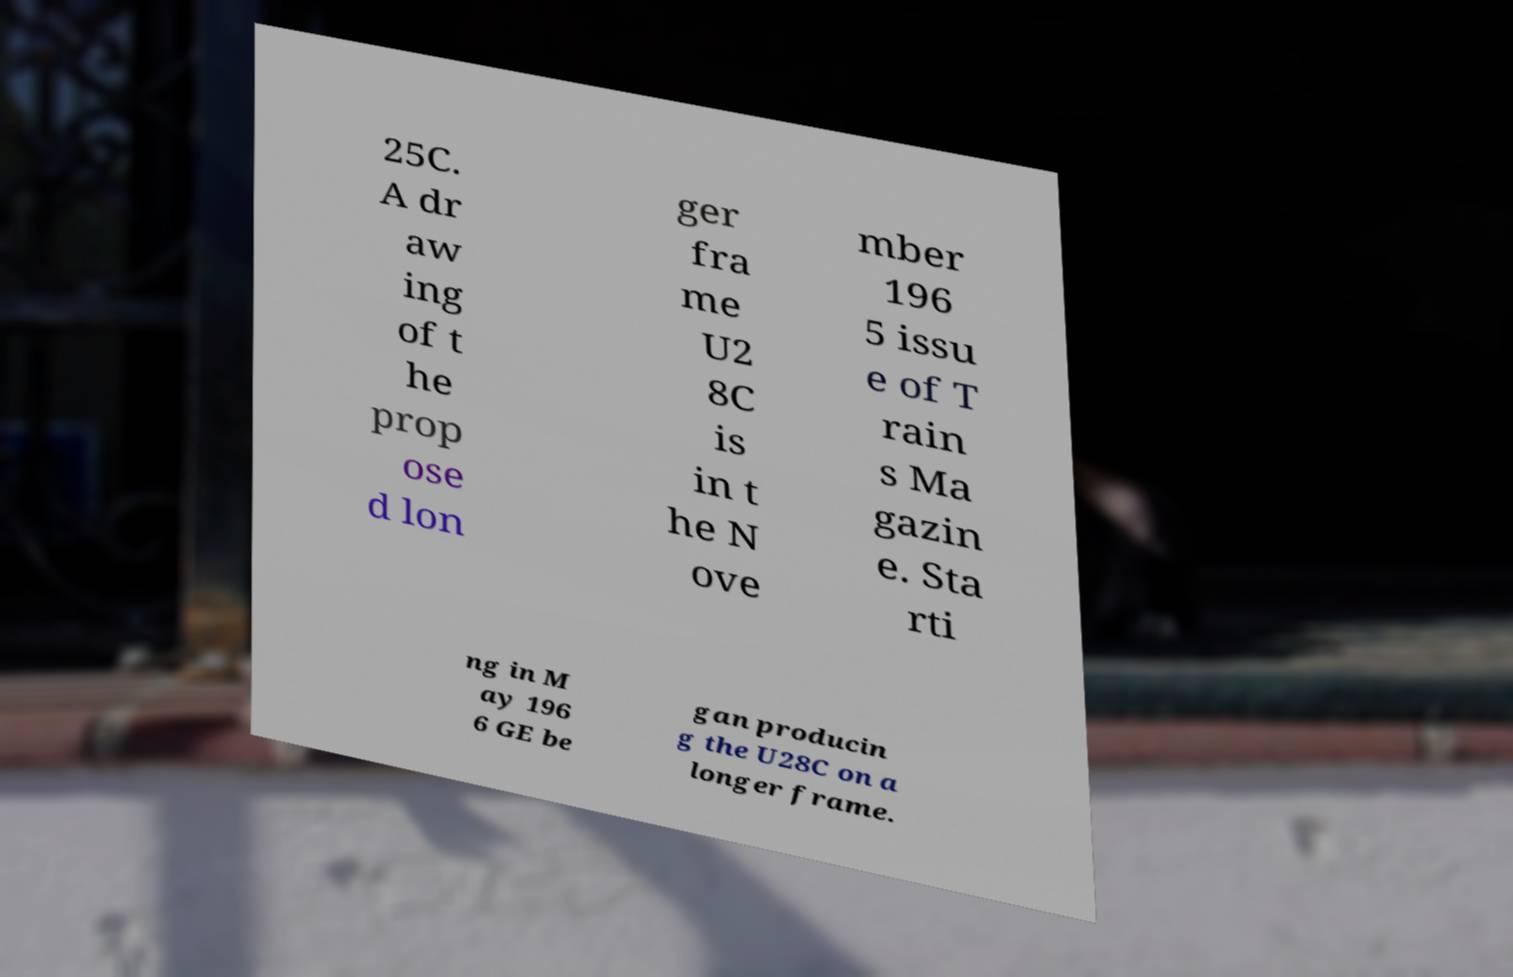What messages or text are displayed in this image? I need them in a readable, typed format. 25C. A dr aw ing of t he prop ose d lon ger fra me U2 8C is in t he N ove mber 196 5 issu e of T rain s Ma gazin e. Sta rti ng in M ay 196 6 GE be gan producin g the U28C on a longer frame. 